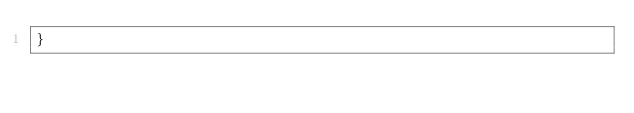Convert code to text. <code><loc_0><loc_0><loc_500><loc_500><_Rust_>}
</code> 